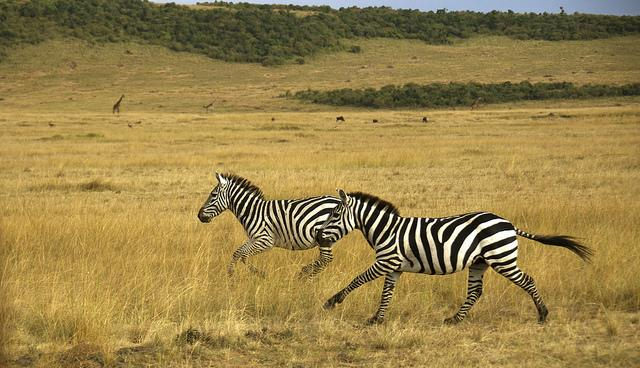How many zebras are running across the savannah plain? two 